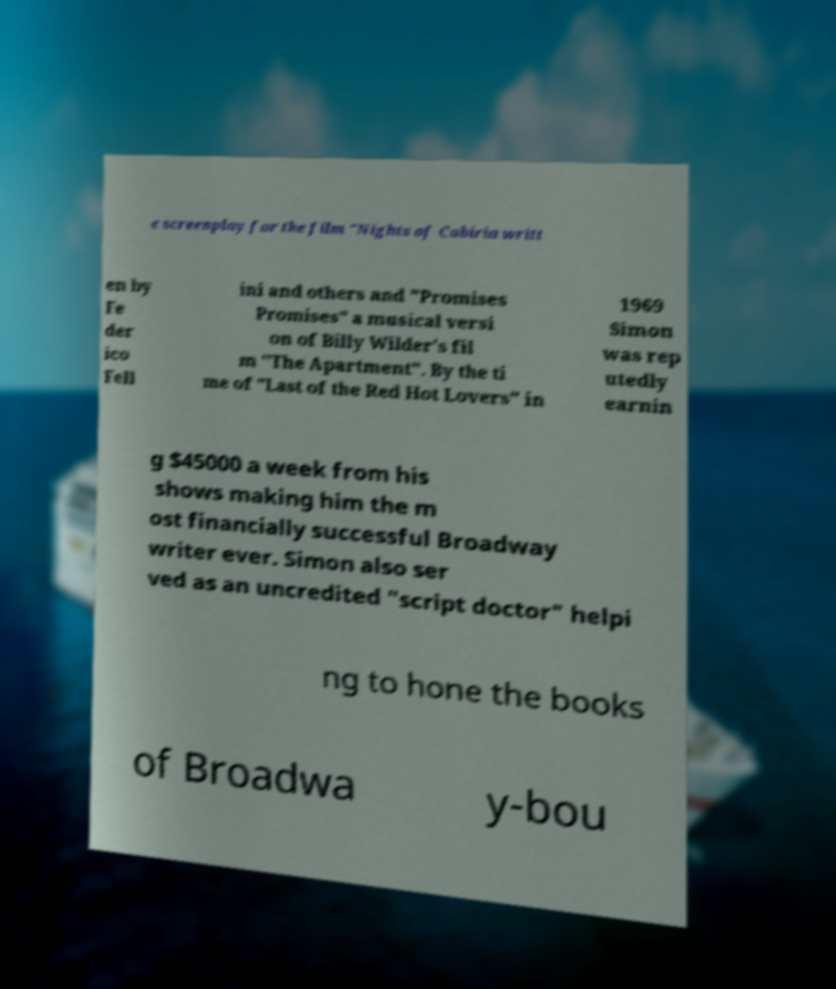I need the written content from this picture converted into text. Can you do that? e screenplay for the film "Nights of Cabiria writt en by Fe der ico Fell ini and others and "Promises Promises" a musical versi on of Billy Wilder's fil m "The Apartment". By the ti me of "Last of the Red Hot Lovers" in 1969 Simon was rep utedly earnin g $45000 a week from his shows making him the m ost financially successful Broadway writer ever. Simon also ser ved as an uncredited "script doctor" helpi ng to hone the books of Broadwa y-bou 